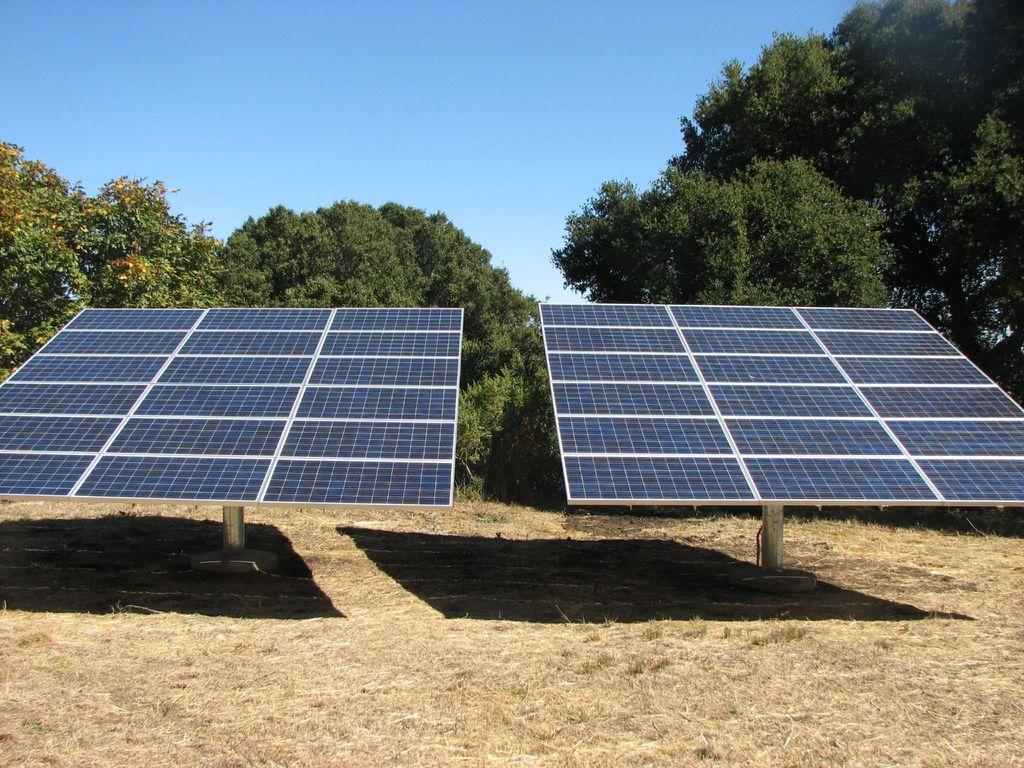What objects are present in the image that generate electricity? There are two solar panels in the image. What can be observed on the ground beneath the solar panels? There are two shadows on the ground in the image. What type of vegetation is visible in the background of the image? There are trees visible in the background of the image. What else can be seen in the background of the image? The sky is visible in the background of the image. What color is the horse's shirt in the image? There is no horse or shirt present in the image. 